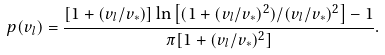Convert formula to latex. <formula><loc_0><loc_0><loc_500><loc_500>p ( v _ { l } ) = \frac { [ 1 + ( v _ { l } / v _ { * } ) ] \ln { \left [ ( 1 + ( v _ { l } / v _ { * } ) ^ { 2 } ) / ( v _ { l } / v _ { * } ) ^ { 2 } \right ] } - 1 } { \pi [ 1 + ( v _ { l } / v _ { * } ) ^ { 2 } ] } .</formula> 